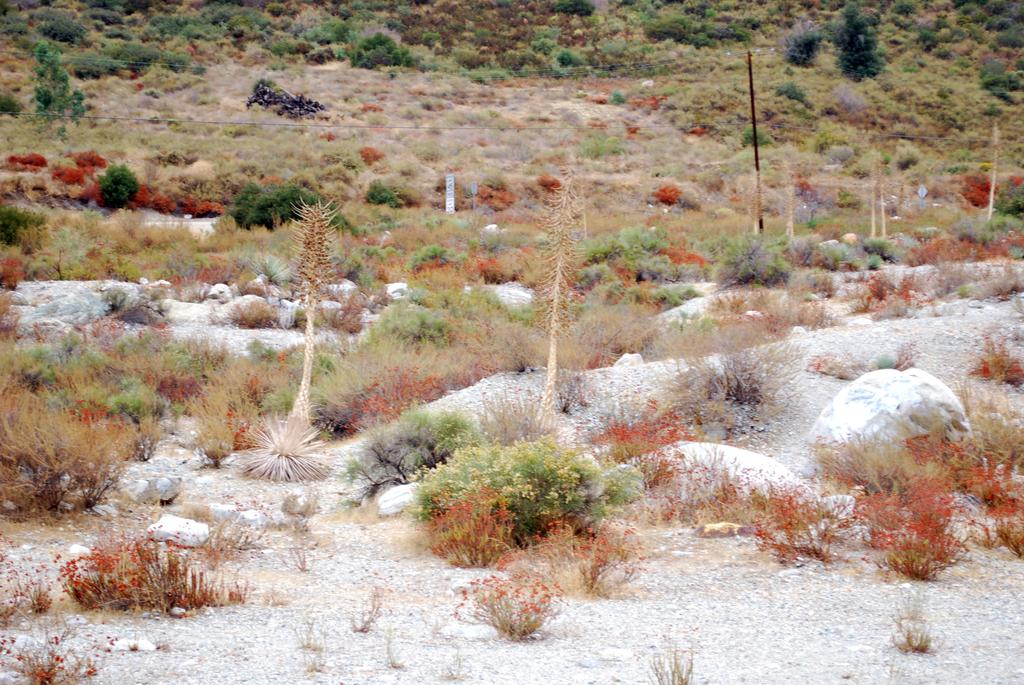What type of living organisms can be seen in the image? Plants can be seen in the image. What other objects are present in the image? There are stones and a pole visible in the image. What is the surface on which the plants and stones are placed? The ground is visible at the bottom of the image. What type of dinosaurs can be seen in the image? There are no dinosaurs present in the image. 